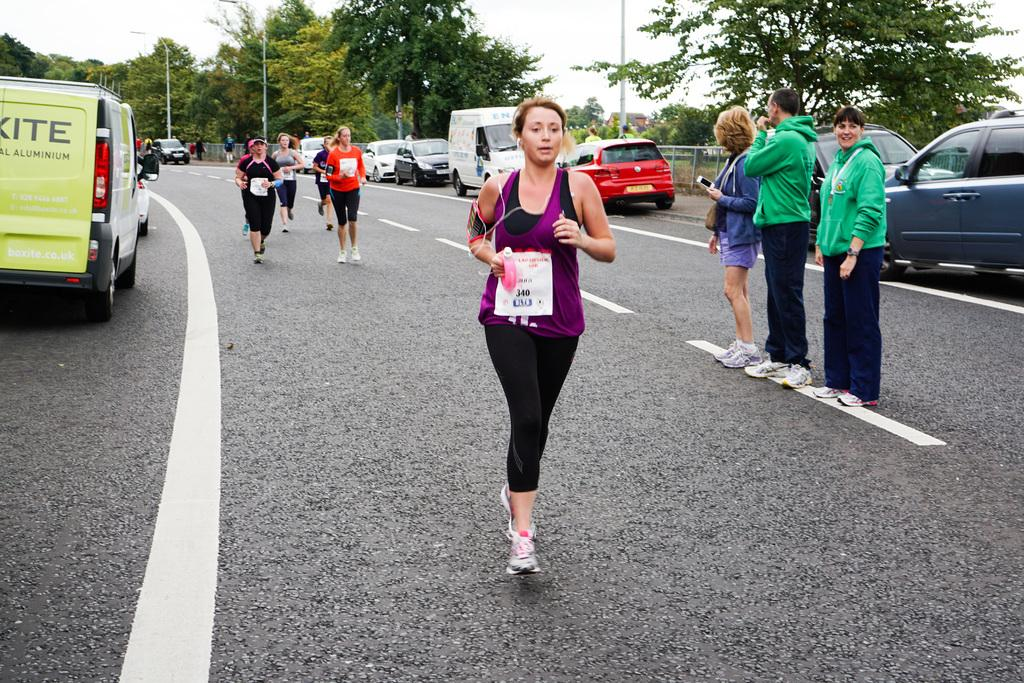<image>
Share a concise interpretation of the image provided. A women in a purple tank and leggings is running down a road with a sign on the front of her with the number 340. 